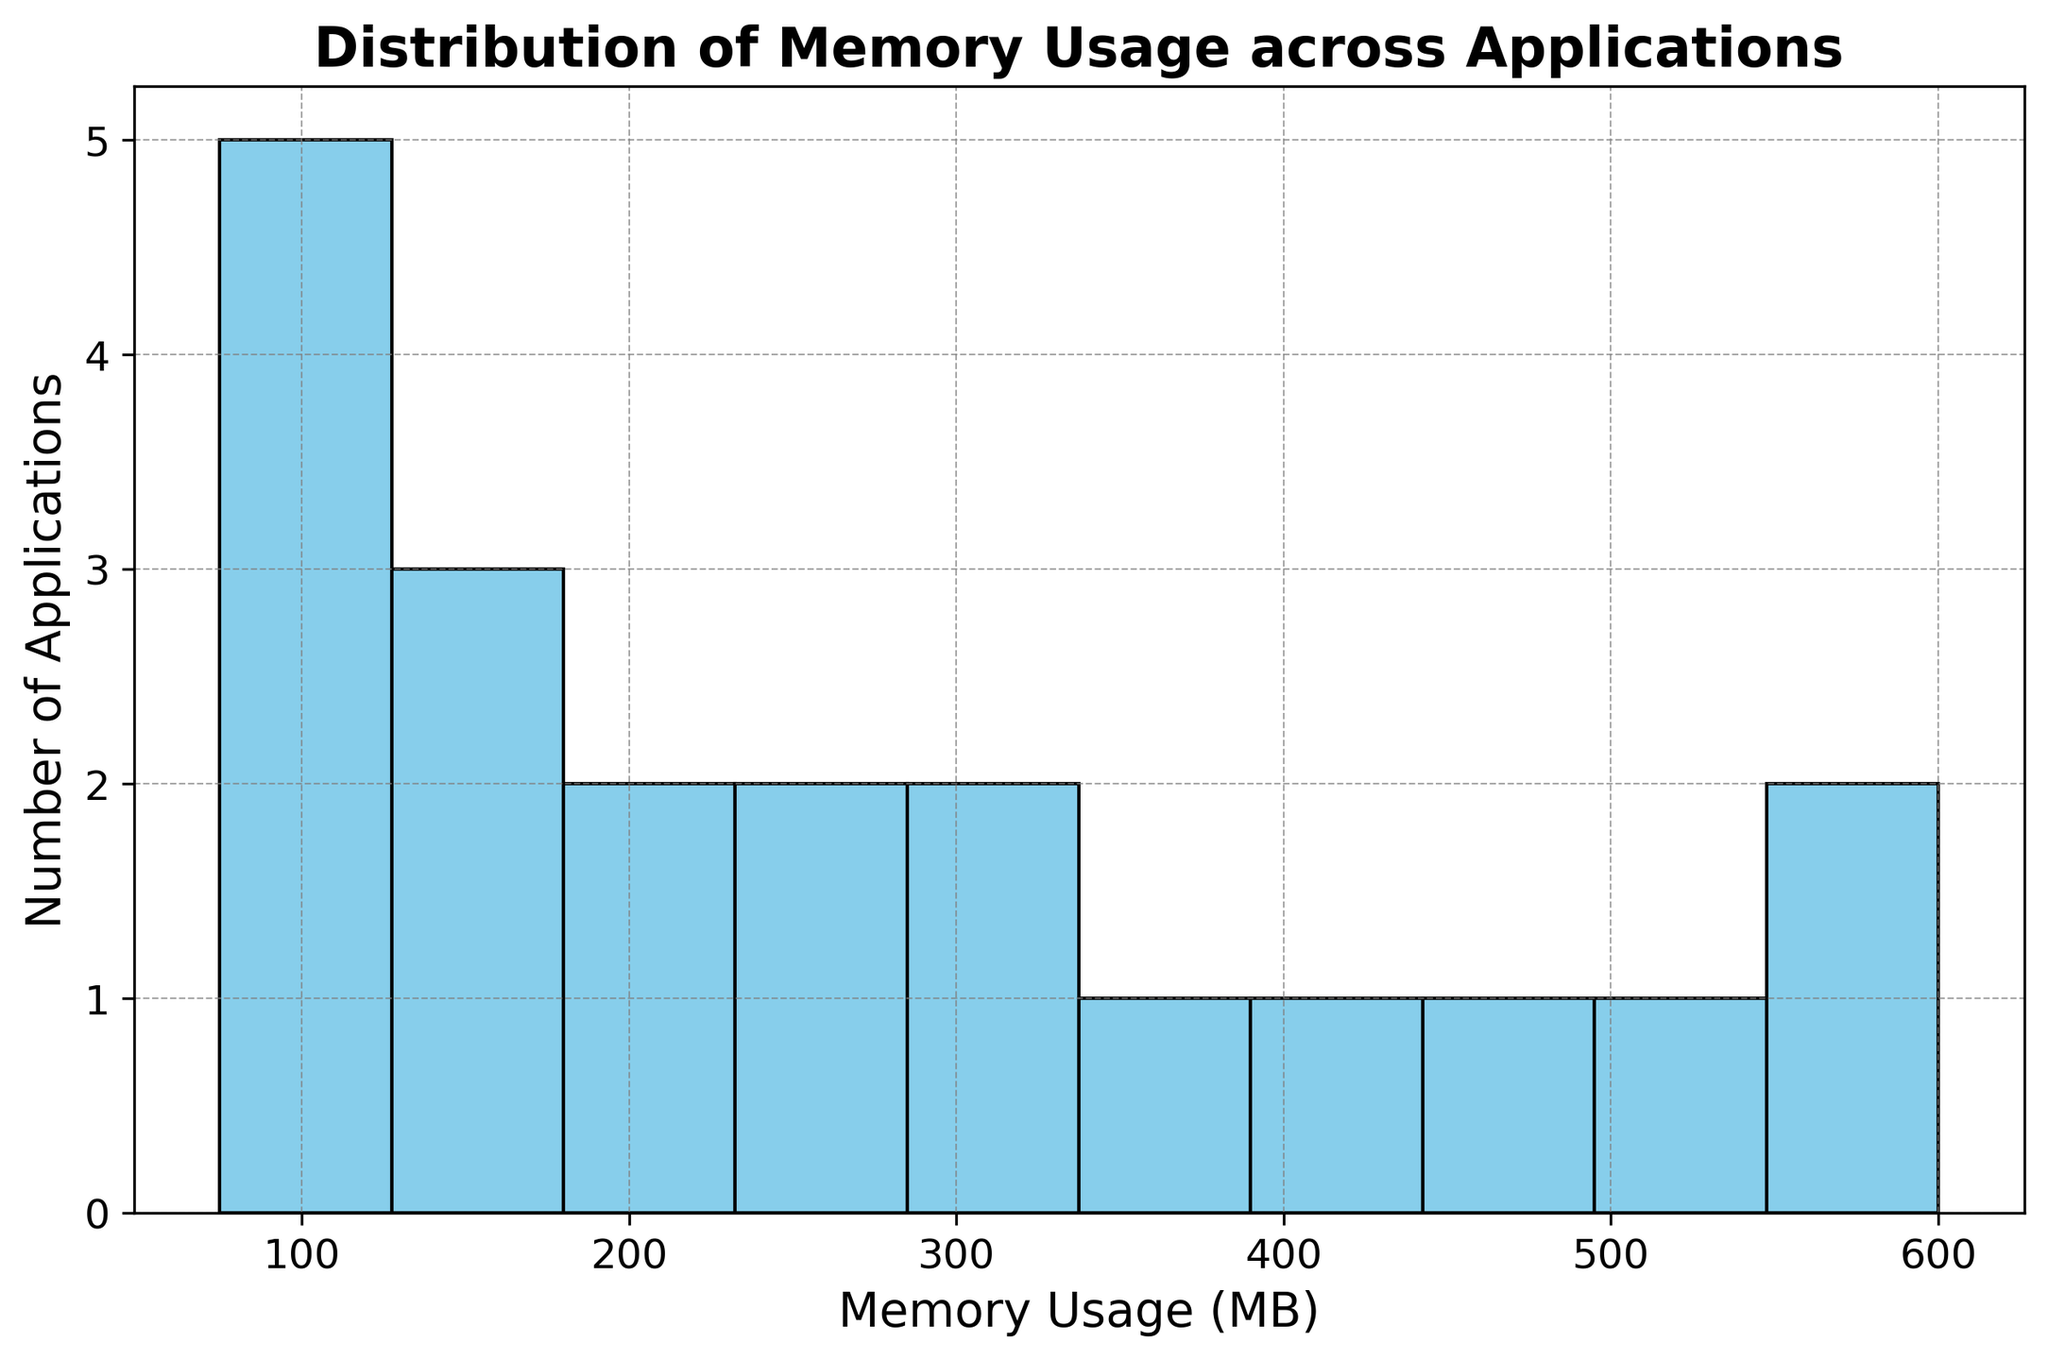What is the range of memory usage covered by the histogram? To find the range of the memory usage, we look at the lowest and the highest bin edges on the x-axis. From the histogram, we see that the lowest bin starts slightly above 0 MB, and the highest bin ends just above 600 MB. Thus, the range is from slightly above 0 MB to just above 600 MB.
Answer: 0 to 600 MB Which bin has the highest count of applications? To determine which bin has the highest count, we look for the tallest bar in the histogram. The tallest bar indicates the bin with the most applications. Counting the bins, the highest count appears in the bin from 200 MB to 250 MB.
Answer: 200-250 MB How many applications fall within the memory usage range of 300-400 MB? To find this, we count the number of bars within the specified range on the x-axis. By counting, we see that bars for 300-350 MB and 350-400 MB are present. Each of these bars represents one range, hence two bars in total.
Answer: 2 What is the approximate average memory usage of the applications? To estimate the average memory usage, we consider the central values of the bins and the height of the bars representing the number of applications in each bin. Summing up the central values weighted by the counts and dividing by the total number of applications would give the average. Given the distribution seems balanced with a peak around 200-300 MB and values ranging from 70 MB to 600 MB, the average would lie around 250-300 MB.
Answer: ~300 MB Is the distribution of memory usage skewed to the left, right, or is it symmetrical? By examining the shape of the histogram, we see whether one tail is longer than the other. The bulk of the distribution appears to be on the left (lower memory usages), with a tail extending further to the right. This indicates a right skew.
Answer: Right-skewed Which memory usage range has the fewest applications? For this, we need to identify the shortest bar in the histogram. The shortest bars are for the usage ranges 75-100 MB and 500-600 MB. By visually assessing both, the bin at 75-100 MB appears shorter.
Answer: 75-100 MB How does the number of applications in the 400-500 MB range compare to the number in the 100-200 MB range? To compare, we count the bars for both ranges. For 400-500 MB, there are two bars. For 100-200 MB, we also have two bars. By visual inspection, the heights of these bins can be compared. The 100-200 MB range has taller bars.
Answer: 100-200 MB has more If an application uses 320 MB of memory, which bin does it fall into? To determine the bin, we need to find where 320 MB lies on the x-axis and which bin contains this value. The bin that includes 300-350 MB will contain the application using 320 MB.
Answer: 300-350 MB What percentage of applications use 250 MB of memory or less? To find this percentage, count the number of applications in bins up to and including the 200-250 MB range, and then divide by the total number of applications. The relevant bins are from 0-50 MB up to 200-250 MB, accounting for 0 applications + those in one bar each totaling a considerable proportion. With total applications being 20, roughly these bins make up near half of the total since many clusters before 250 MB.
Answer: ~50% 